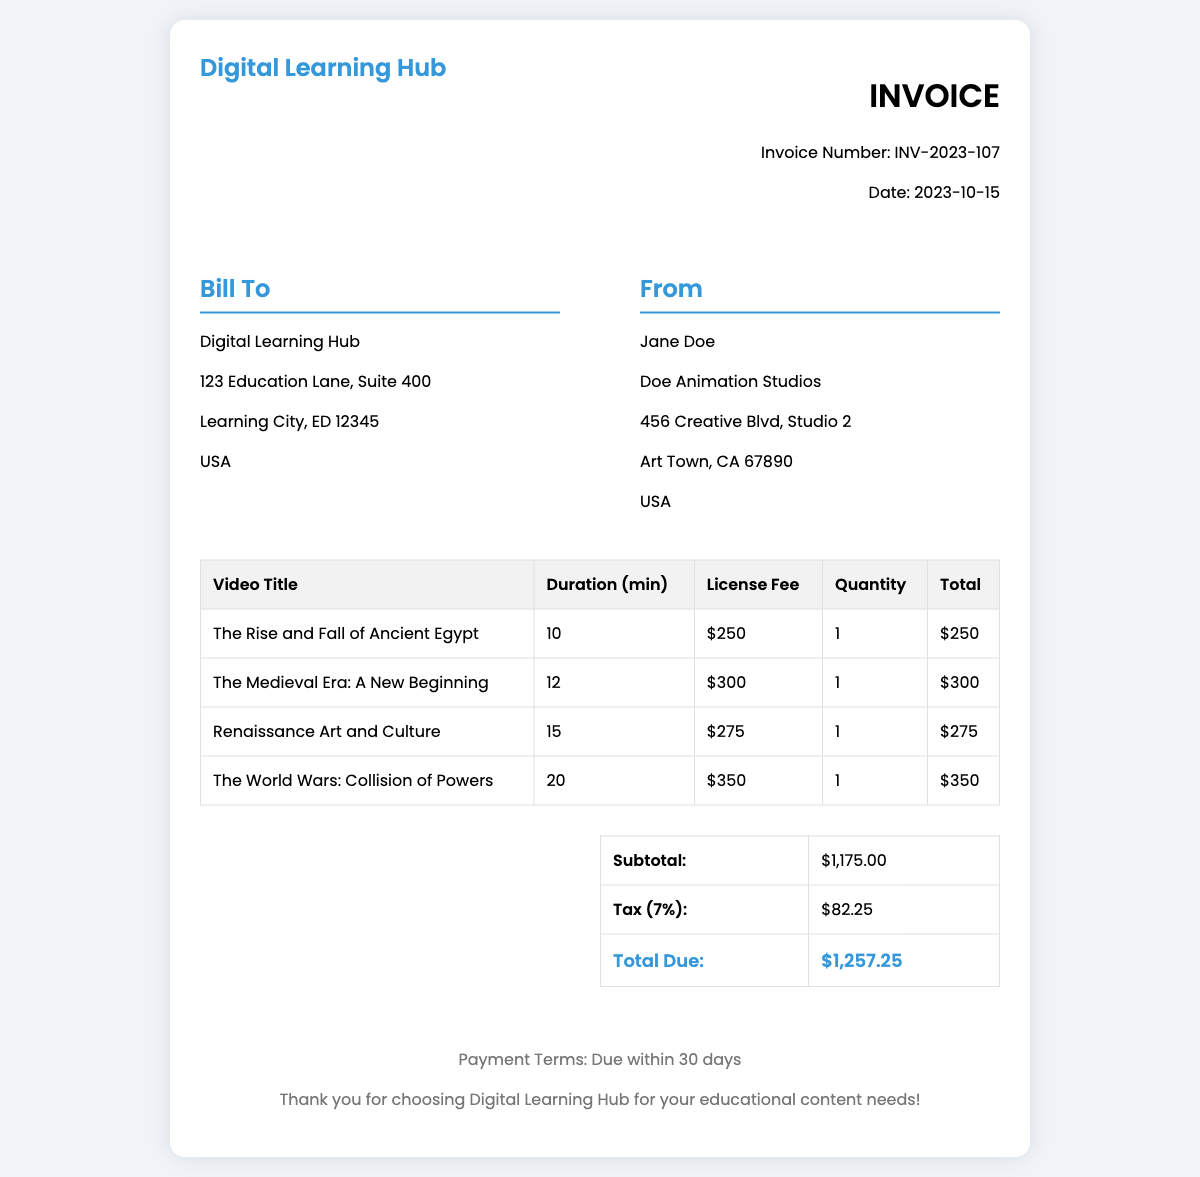What is the invoice number? The invoice number is provided in the document as INV-2023-107.
Answer: INV-2023-107 What is the total amount due? The total amount due is calculated as the subtotal plus tax, which is $1,175.00 + $82.25 = $1,257.25.
Answer: $1,257.25 What is the license fee for "The Medieval Era: A New Beginning"? The license fee for this video is listed in the table as $300.
Answer: $300 How many videos are included in this invoice? The total count of videos can be derived from the table, which lists 4 titles.
Answer: 4 What is the tax rate applied in this invoice? The tax rate is provided in the summary as 7%.
Answer: 7% What is the duration of "The World Wars: Collision of Powers"? The duration of this video is recorded in the table as 20 minutes.
Answer: 20 minutes Who is the sender of the invoice? The sender's name is listed as Jane Doe from Doe Animation Studios.
Answer: Jane Doe What is the subtotal before tax? The subtotal before tax is also provided in the summary section as $1,175.00.
Answer: $1,175.00 What is the payment term specified in the footer? The payment term specifies that payment is due within 30 days.
Answer: Due within 30 days 